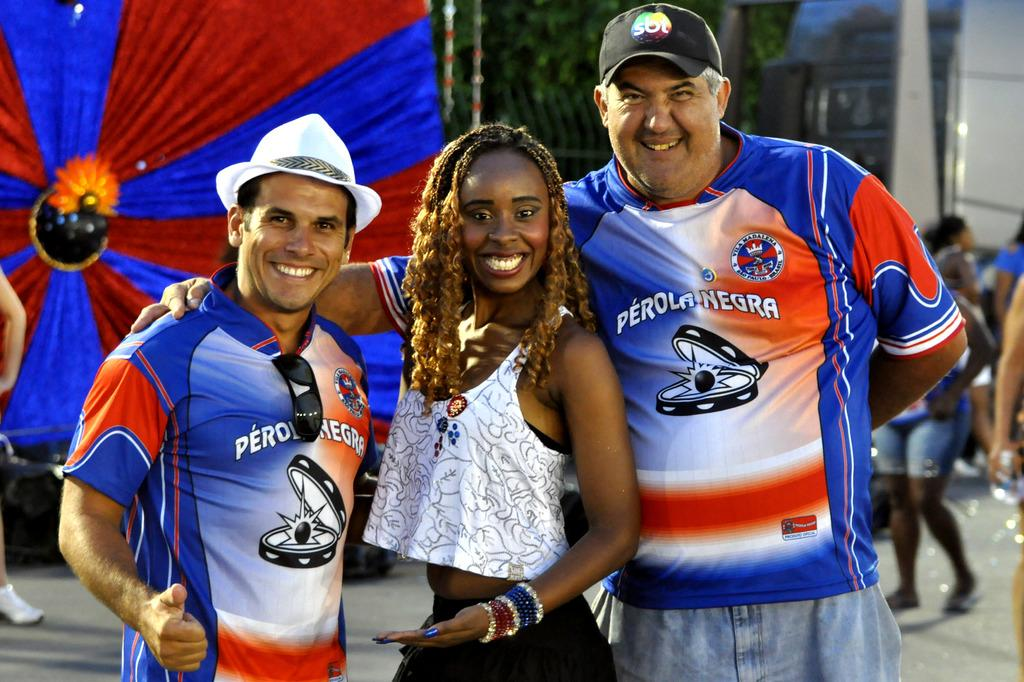<image>
Render a clear and concise summary of the photo. Two men wearing Perola Negra shirts flank a woman and pose for a picture. 